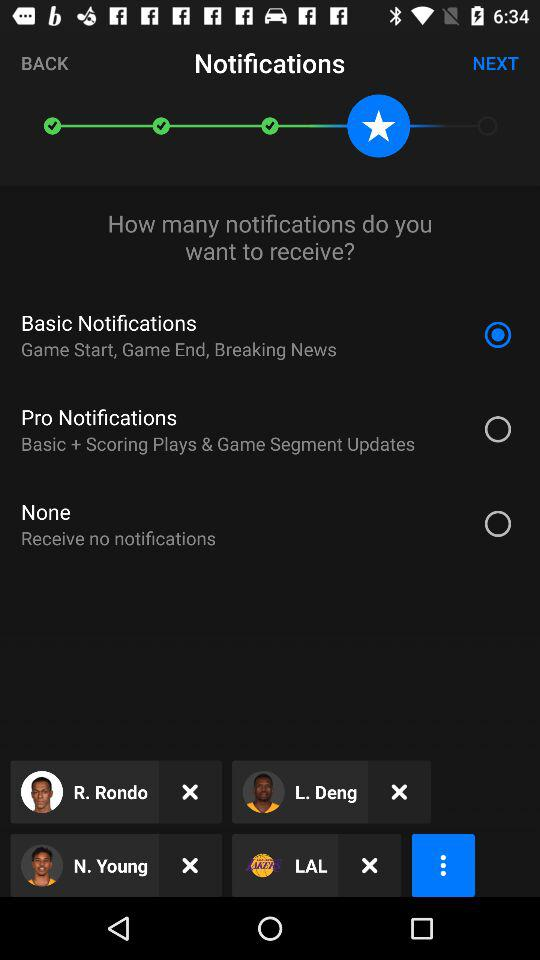What kind of information will the basic notifications provide? The basic notifications will provide information about game start, game end and breaking news. 